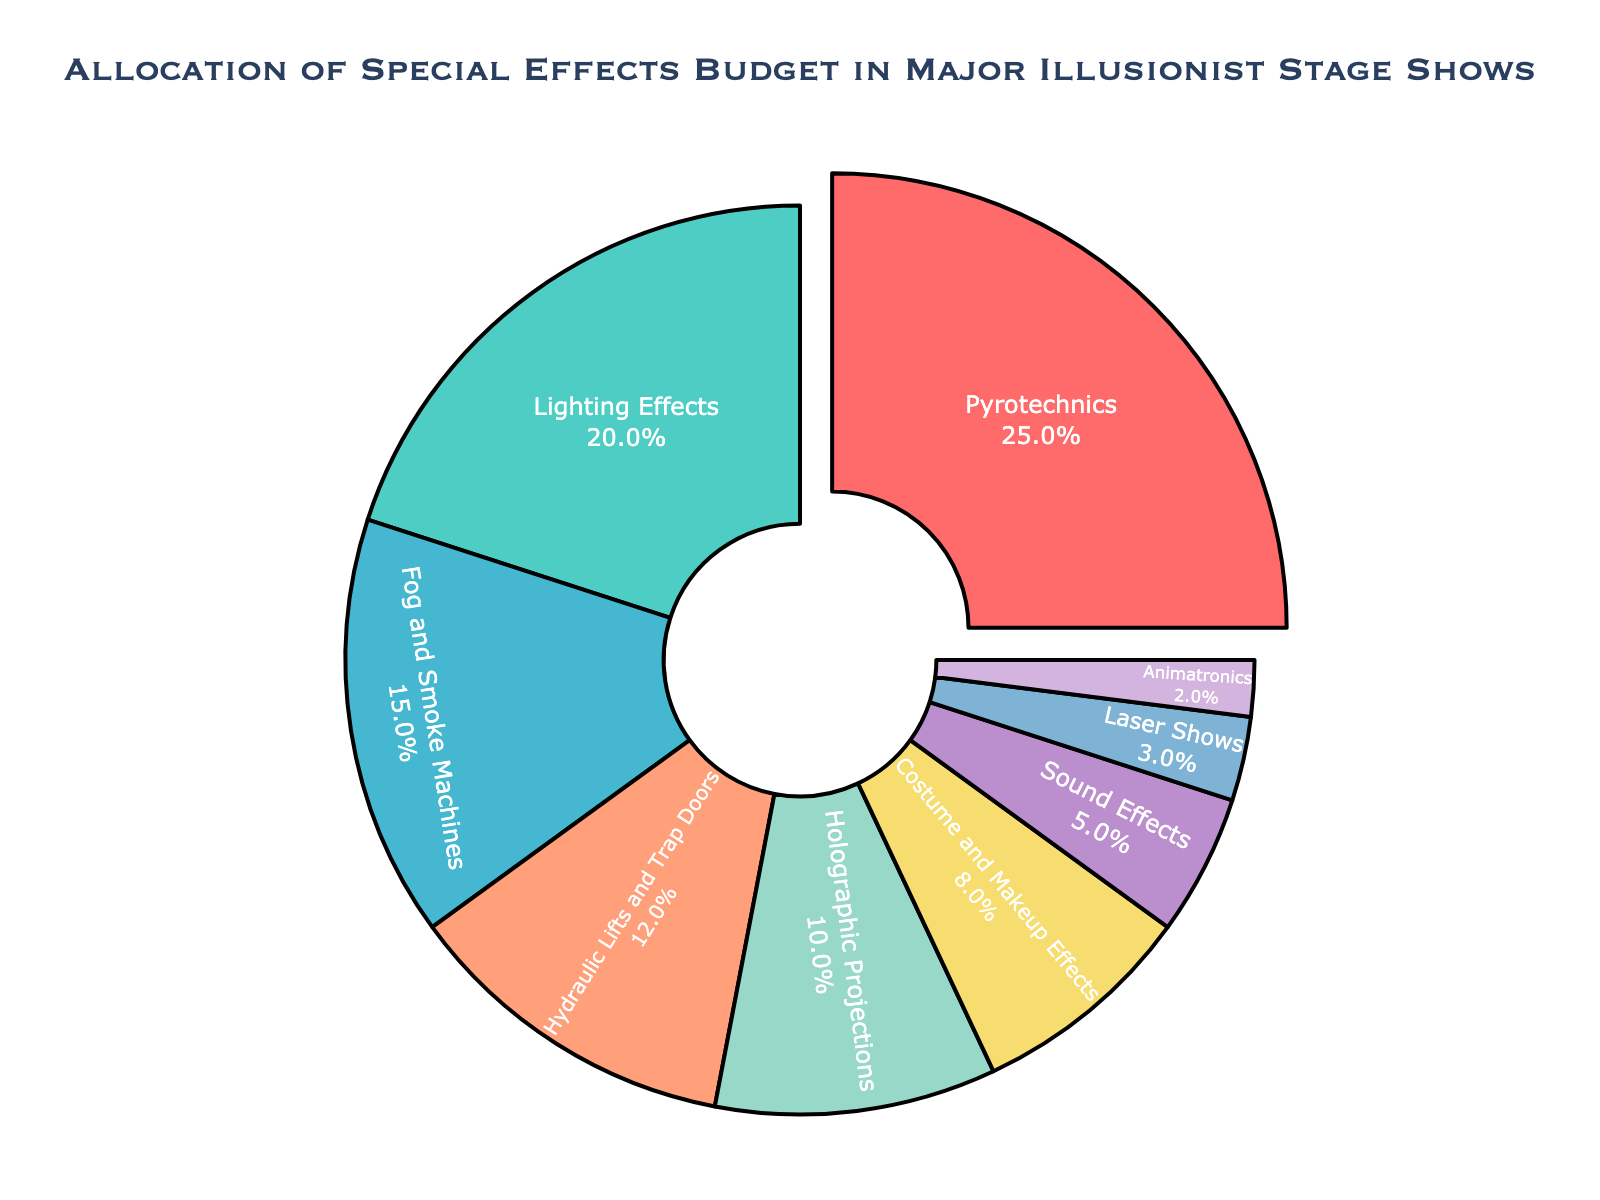What category receives the highest allocation of the special effects budget? The category with the largest portion of the pie chart is the one with the highest allocation. In this chart, the largest segment is for "Pyrotechnics."
Answer: Pyrotechnics What is the total percentage allocated to Lighting Effects and Fog and Smoke Machines combined? To find the total percentage, simply add the percentage values for "Lighting Effects" and "Fog and Smoke Machines" from the chart. Lighting Effects is 20%, and Fog and Smoke Machines is 15%, so 20% + 15% = 35%.
Answer: 35% Which category receives more budget allocation: Costume and Makeup Effects or Hydraulic Lifts and Trap Doors? Compare the percentage values for both categories from the chart. Costume and Makeup Effects have 8%, while Hydraulic Lifts and Trap Doors have 12%. Since 12% > 8%, the Hydraulic Lifts and Trap Doors category receives more budget.
Answer: Hydraulic Lifts and Trap Doors What is the difference in budget allocation between Pyrotechnics and Holographic Projections? Subtract the percentage of Holographic Projections from the percentage of Pyrotechnics. Pyrotechnics have 25%, and Holographic Projections have 10%. So, the difference is 25% - 10% = 15%.
Answer: 15% What is the combined budget allocation for categories that each have an allocation of less than 10%? Identify the categories with less than 10%: "Costume and Makeup Effects" (8%), "Sound Effects" (5%), "Laser Shows" (3%), "Animatronics" (2%). Then, sum these percentages: 8% + 5% + 3% + 2% = 18%.
Answer: 18% Which visual attribute distinguishes the Pyrotechnics category in the pie chart? The Pyrotechnics segment is visually distinct because it is "pulled out" or separated slightly from the rest of the pie chart.
Answer: Pulled out Is the budget allocation for Laser Shows greater than, less than, or equal to that for Fog and Smoke Machines? Compare the percentages from the chart. Laser Shows have 3%, while Fog and Smoke Machines have 15%. Since 3% is less than 15%, the allocation for Laser Shows is less than that for Fog and Smoke Machines.
Answer: Less than How much more budget allocation does Lighting Effects have compared to Animatronics? Subtract the percentage of Animatronics from the percentage of Lighting Effects. Lighting Effects have 20%, and Animatronics have 2%. So, 20% - 2% = 18%.
Answer: 18% What's the difference in total percentage points between the three categories with the smallest budget allocations and Pyrotechnics? Identify the three smallest budget allocations: "Animatronics" (2%), "Laser Shows" (3%), "Sound Effects" (5%). Sum these up: 2% + 3% + 5% = 10%. Subtract this sum from the percentage for Pyrotechnics (25%): 25% - 10% = 15%.
Answer: 15% 